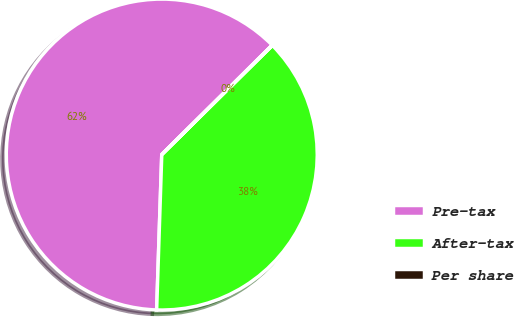Convert chart. <chart><loc_0><loc_0><loc_500><loc_500><pie_chart><fcel>Pre-tax<fcel>After-tax<fcel>Per share<nl><fcel>62.05%<fcel>37.92%<fcel>0.03%<nl></chart> 